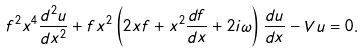Convert formula to latex. <formula><loc_0><loc_0><loc_500><loc_500>f ^ { 2 } x ^ { 4 } \frac { d ^ { 2 } u } { d x ^ { 2 } } + f x ^ { 2 } \left ( 2 x f + x ^ { 2 } \frac { d f } { d x } + 2 i \omega \right ) \frac { d u } { d x } - V u = 0 .</formula> 